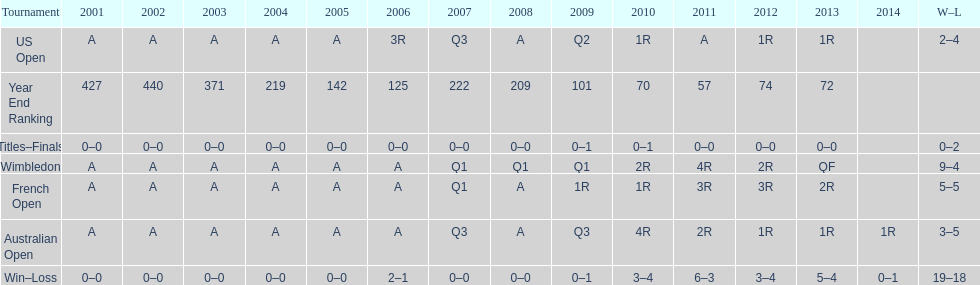What tournament has 5-5 as it's "w-l" record? French Open. 